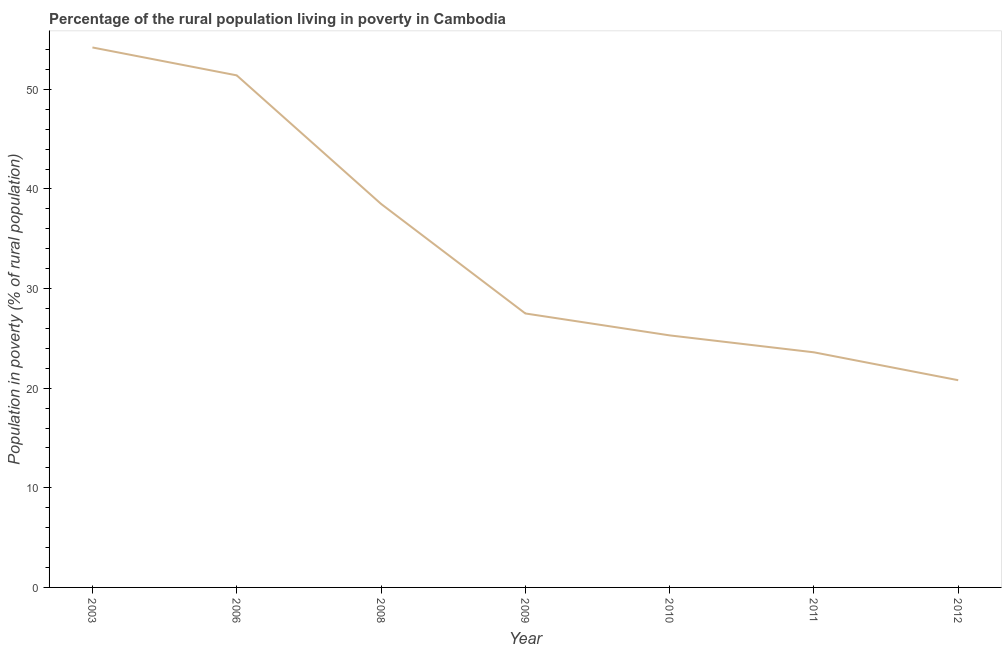What is the percentage of rural population living below poverty line in 2008?
Provide a succinct answer. 38.5. Across all years, what is the maximum percentage of rural population living below poverty line?
Offer a terse response. 54.2. Across all years, what is the minimum percentage of rural population living below poverty line?
Offer a terse response. 20.8. In which year was the percentage of rural population living below poverty line maximum?
Offer a very short reply. 2003. What is the sum of the percentage of rural population living below poverty line?
Keep it short and to the point. 241.3. What is the difference between the percentage of rural population living below poverty line in 2003 and 2011?
Offer a very short reply. 30.6. What is the average percentage of rural population living below poverty line per year?
Keep it short and to the point. 34.47. In how many years, is the percentage of rural population living below poverty line greater than 42 %?
Offer a terse response. 2. What is the ratio of the percentage of rural population living below poverty line in 2003 to that in 2010?
Keep it short and to the point. 2.14. Is the percentage of rural population living below poverty line in 2009 less than that in 2010?
Offer a terse response. No. What is the difference between the highest and the second highest percentage of rural population living below poverty line?
Your response must be concise. 2.8. Is the sum of the percentage of rural population living below poverty line in 2009 and 2012 greater than the maximum percentage of rural population living below poverty line across all years?
Your answer should be very brief. No. What is the difference between the highest and the lowest percentage of rural population living below poverty line?
Keep it short and to the point. 33.4. Are the values on the major ticks of Y-axis written in scientific E-notation?
Make the answer very short. No. Does the graph contain grids?
Offer a very short reply. No. What is the title of the graph?
Keep it short and to the point. Percentage of the rural population living in poverty in Cambodia. What is the label or title of the X-axis?
Your response must be concise. Year. What is the label or title of the Y-axis?
Your response must be concise. Population in poverty (% of rural population). What is the Population in poverty (% of rural population) of 2003?
Offer a very short reply. 54.2. What is the Population in poverty (% of rural population) of 2006?
Offer a very short reply. 51.4. What is the Population in poverty (% of rural population) of 2008?
Provide a succinct answer. 38.5. What is the Population in poverty (% of rural population) of 2010?
Give a very brief answer. 25.3. What is the Population in poverty (% of rural population) in 2011?
Ensure brevity in your answer.  23.6. What is the Population in poverty (% of rural population) of 2012?
Give a very brief answer. 20.8. What is the difference between the Population in poverty (% of rural population) in 2003 and 2009?
Your answer should be very brief. 26.7. What is the difference between the Population in poverty (% of rural population) in 2003 and 2010?
Your answer should be compact. 28.9. What is the difference between the Population in poverty (% of rural population) in 2003 and 2011?
Your response must be concise. 30.6. What is the difference between the Population in poverty (% of rural population) in 2003 and 2012?
Provide a succinct answer. 33.4. What is the difference between the Population in poverty (% of rural population) in 2006 and 2008?
Give a very brief answer. 12.9. What is the difference between the Population in poverty (% of rural population) in 2006 and 2009?
Ensure brevity in your answer.  23.9. What is the difference between the Population in poverty (% of rural population) in 2006 and 2010?
Offer a very short reply. 26.1. What is the difference between the Population in poverty (% of rural population) in 2006 and 2011?
Give a very brief answer. 27.8. What is the difference between the Population in poverty (% of rural population) in 2006 and 2012?
Ensure brevity in your answer.  30.6. What is the difference between the Population in poverty (% of rural population) in 2008 and 2010?
Make the answer very short. 13.2. What is the difference between the Population in poverty (% of rural population) in 2008 and 2012?
Ensure brevity in your answer.  17.7. What is the difference between the Population in poverty (% of rural population) in 2009 and 2010?
Your response must be concise. 2.2. What is the difference between the Population in poverty (% of rural population) in 2009 and 2012?
Make the answer very short. 6.7. What is the difference between the Population in poverty (% of rural population) in 2010 and 2012?
Your response must be concise. 4.5. What is the ratio of the Population in poverty (% of rural population) in 2003 to that in 2006?
Offer a terse response. 1.05. What is the ratio of the Population in poverty (% of rural population) in 2003 to that in 2008?
Your answer should be compact. 1.41. What is the ratio of the Population in poverty (% of rural population) in 2003 to that in 2009?
Offer a terse response. 1.97. What is the ratio of the Population in poverty (% of rural population) in 2003 to that in 2010?
Provide a succinct answer. 2.14. What is the ratio of the Population in poverty (% of rural population) in 2003 to that in 2011?
Make the answer very short. 2.3. What is the ratio of the Population in poverty (% of rural population) in 2003 to that in 2012?
Give a very brief answer. 2.61. What is the ratio of the Population in poverty (% of rural population) in 2006 to that in 2008?
Your response must be concise. 1.33. What is the ratio of the Population in poverty (% of rural population) in 2006 to that in 2009?
Offer a very short reply. 1.87. What is the ratio of the Population in poverty (% of rural population) in 2006 to that in 2010?
Your answer should be compact. 2.03. What is the ratio of the Population in poverty (% of rural population) in 2006 to that in 2011?
Provide a short and direct response. 2.18. What is the ratio of the Population in poverty (% of rural population) in 2006 to that in 2012?
Your response must be concise. 2.47. What is the ratio of the Population in poverty (% of rural population) in 2008 to that in 2010?
Your answer should be compact. 1.52. What is the ratio of the Population in poverty (% of rural population) in 2008 to that in 2011?
Provide a short and direct response. 1.63. What is the ratio of the Population in poverty (% of rural population) in 2008 to that in 2012?
Offer a terse response. 1.85. What is the ratio of the Population in poverty (% of rural population) in 2009 to that in 2010?
Keep it short and to the point. 1.09. What is the ratio of the Population in poverty (% of rural population) in 2009 to that in 2011?
Provide a succinct answer. 1.17. What is the ratio of the Population in poverty (% of rural population) in 2009 to that in 2012?
Your answer should be very brief. 1.32. What is the ratio of the Population in poverty (% of rural population) in 2010 to that in 2011?
Provide a succinct answer. 1.07. What is the ratio of the Population in poverty (% of rural population) in 2010 to that in 2012?
Offer a terse response. 1.22. What is the ratio of the Population in poverty (% of rural population) in 2011 to that in 2012?
Give a very brief answer. 1.14. 